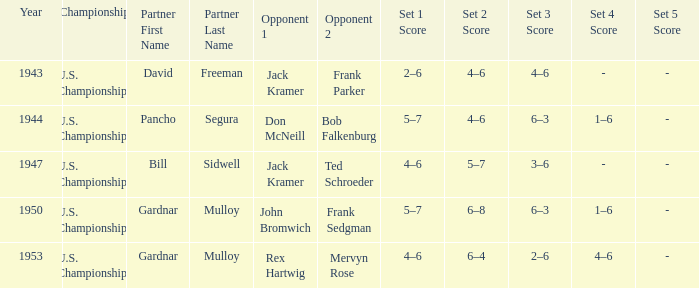Which Opponents in the final have a Score of 4–6, 6–4, 2–6, 4–6? Rex Hartwig Mervyn Rose. 